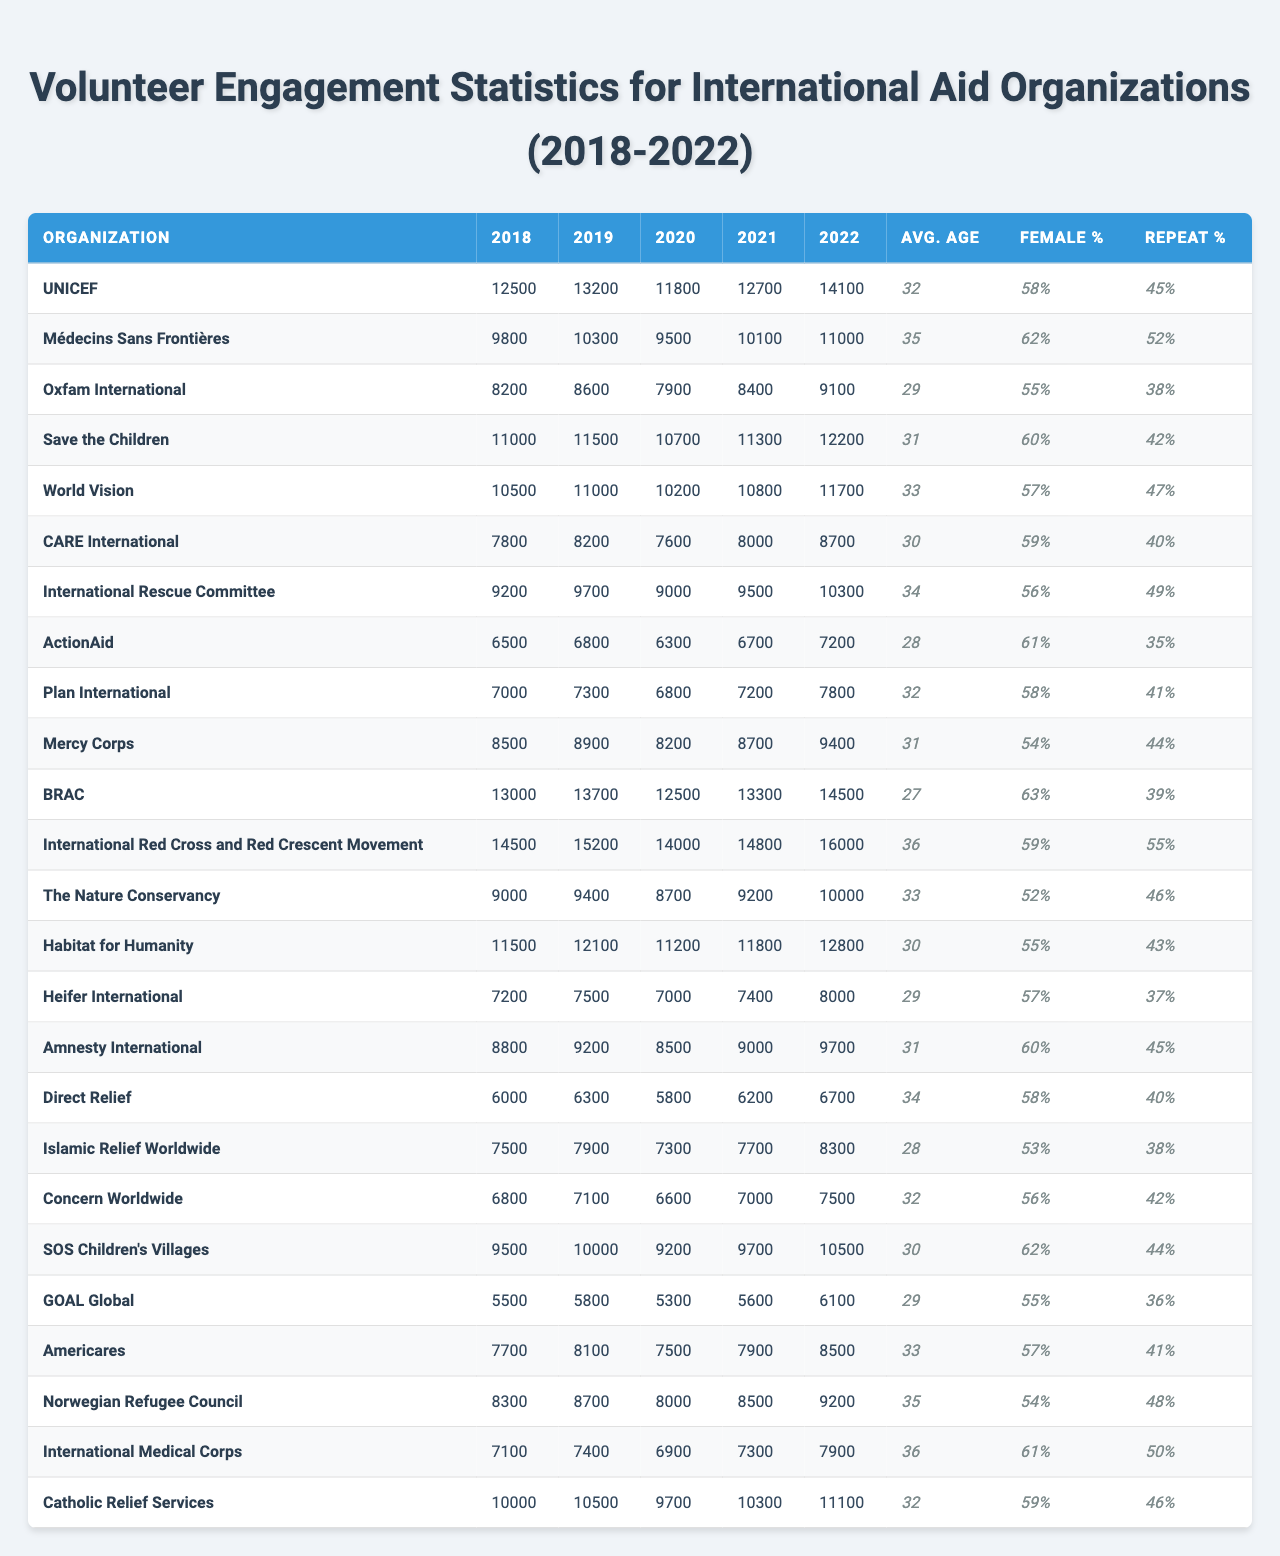What is the total number of volunteers for "World Vision" in 2022? To find the total number of volunteers for "World Vision" in 2022, we can look directly at the column for 2022 under the row for "World Vision." The number there is 11,700.
Answer: 11,700 Which organization had the highest number of volunteers in 2018? By examining the 2018 column for all organizations, "International Red Cross and Red Crescent Movement" had the highest number with 14,500 volunteers.
Answer: 14,500 What is the average age of volunteers in "Médecins Sans Frontières"? In the row for "Médecins Sans Frontières," the average age is listed as 35 years.
Answer: 35 How many organizations had more than 60% female volunteers in 2022? We need to check the female percentage in the 2022 column for each organization. Only "BRAC," "Médecins Sans Frontières," "Save the Children," "Amnesty International," SOS Children's Villages, and “CARE International” had more than 60%. Therefore, there are 6 organizations.
Answer: 6 Which organization has the lowest total number of volunteers over all five years combined? To find this, we need to sum the number of volunteers for each organization from 2018 to 2022, and compare the totals. "GOAL Global" has the lowest total of 28,400 volunteers (5,500 + 5,800 + 5,300 + 5,600 + 6,100).
Answer: GOAL Global What is the female percentage of the organization with the highest average age of volunteers? The highest average age can be found by checking all the average ages. "International Red Cross and Red Crescent Movement" has an average age of 36 and a female percentage of 59%.
Answer: 59% Did the number of volunteers for "Direct Relief" increase every year from 2018 to 2022? Checking the values for "Direct Relief," we see fluctuations (6,000 in 2018, 6,300 in 2019, 5,800 in 2020, 6,200 in 2021 and 6,700 in 2022), indicating it did not increase every year.
Answer: No What is the difference in the number of repeat volunteers between "BRAC" and "CARE International"? For "BRAC," the repeat volunteers percentage is 39%, and for "CARE International," it is 40%. The difference is
Answer: 1% How many organizations had an average age of volunteers below 30? Looking at the average ages listed, organizations with average ages below 30 are "BRAC" (27), "ActionAid" (28), and "Islamic Relief Worldwide" (28). Thus, there are 3 such organizations.
Answer: 3 What was the percentage increase of volunteers for "Save the Children" from 2018 to 2022? "Save the Children" had 11,000 in 2018 and increased to 12,200 in 2022. To calculate the percentage increase, use the formula: ((12,200 - 11,000) / 11,000) * 100 = 10.91%.
Answer: 10.91% 